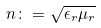<formula> <loc_0><loc_0><loc_500><loc_500>n \colon = \sqrt { \epsilon _ { r } \mu _ { r } }</formula> 